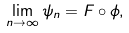Convert formula to latex. <formula><loc_0><loc_0><loc_500><loc_500>\lim _ { n \to \infty } \psi _ { n } = F \circ \phi ,</formula> 